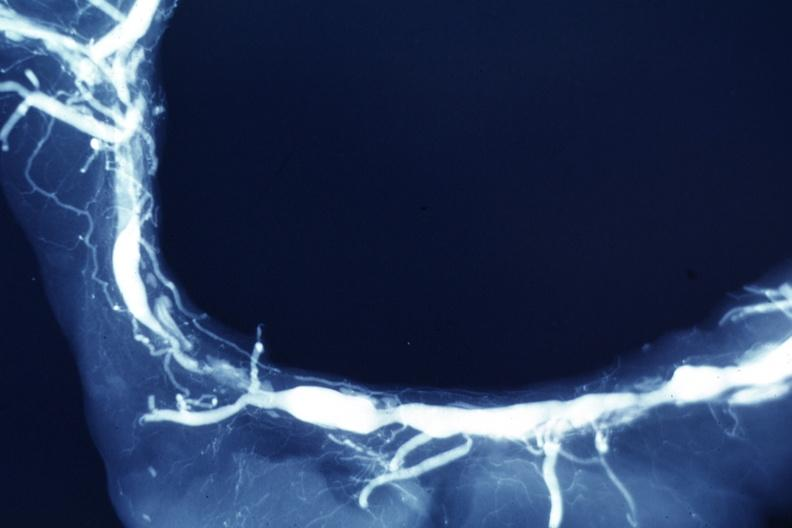what is present?
Answer the question using a single word or phrase. Cardiovascular 